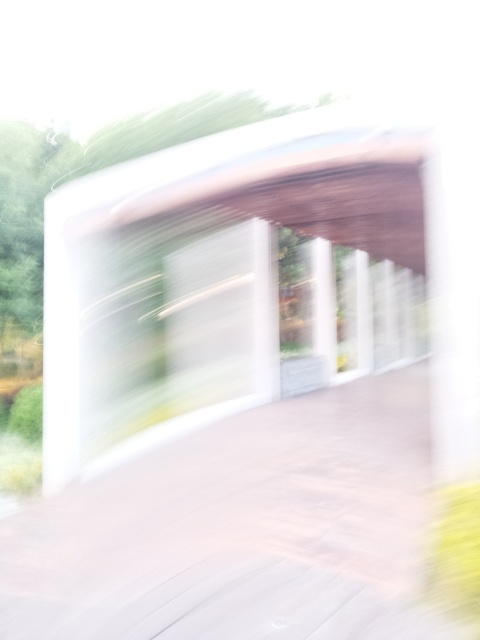Could you provide some tips on how to prevent images like this from turning out blurry? Absolutely! To prevent blurry images, one should use a faster shutter speed to freeze motion, ensure the camera is stable, possibly using a tripod or other steady surface, and use the camera's autofocus feature to maintain sharp focus on the subject. Additionally, increasing the ISO setting can help capture clearer photos in low-light conditions without reducing the shutter speed too much. 